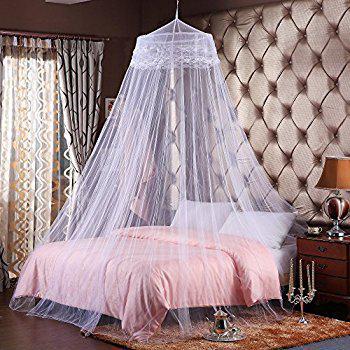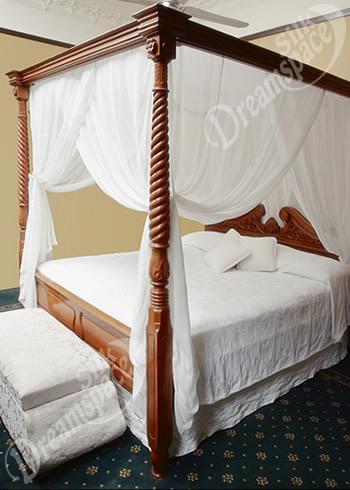The first image is the image on the left, the second image is the image on the right. Examine the images to the left and right. Is the description "All bed drapery is hanging from a central point above a bed." accurate? Answer yes or no. No. 